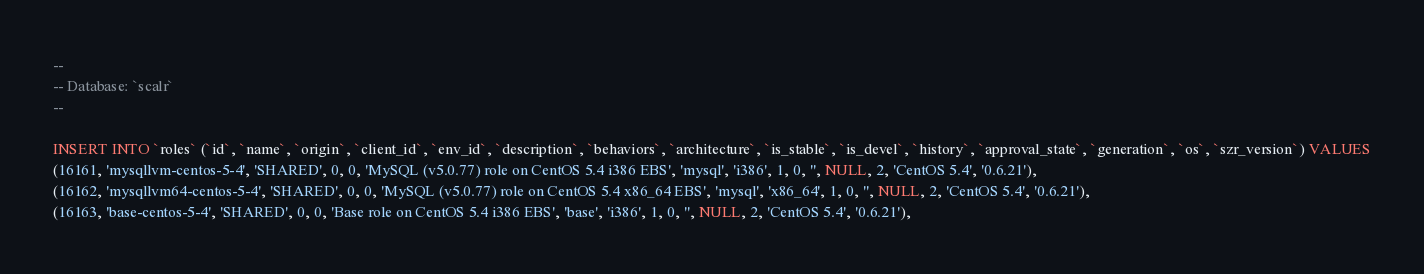<code> <loc_0><loc_0><loc_500><loc_500><_SQL_>--
-- Database: `scalr`
--

INSERT INTO `roles` (`id`, `name`, `origin`, `client_id`, `env_id`, `description`, `behaviors`, `architecture`, `is_stable`, `is_devel`, `history`, `approval_state`, `generation`, `os`, `szr_version`) VALUES
(16161, 'mysqllvm-centos-5-4', 'SHARED', 0, 0, 'MySQL (v5.0.77) role on CentOS 5.4 i386 EBS', 'mysql', 'i386', 1, 0, '', NULL, 2, 'CentOS 5.4', '0.6.21'),
(16162, 'mysqllvm64-centos-5-4', 'SHARED', 0, 0, 'MySQL (v5.0.77) role on CentOS 5.4 x86_64 EBS', 'mysql', 'x86_64', 1, 0, '', NULL, 2, 'CentOS 5.4', '0.6.21'),
(16163, 'base-centos-5-4', 'SHARED', 0, 0, 'Base role on CentOS 5.4 i386 EBS', 'base', 'i386', 1, 0, '', NULL, 2, 'CentOS 5.4', '0.6.21'),</code> 